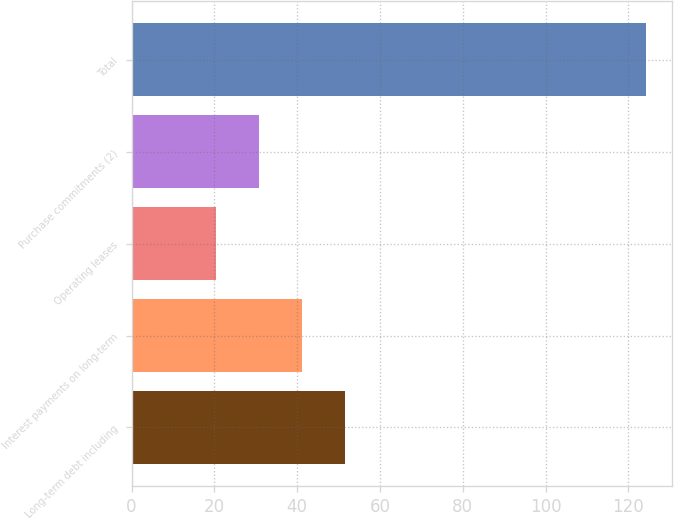Convert chart. <chart><loc_0><loc_0><loc_500><loc_500><bar_chart><fcel>Long-term debt including<fcel>Interest payments on long-term<fcel>Operating leases<fcel>Purchase commitments (2)<fcel>Total<nl><fcel>51.5<fcel>41.1<fcel>20.3<fcel>30.7<fcel>124.3<nl></chart> 